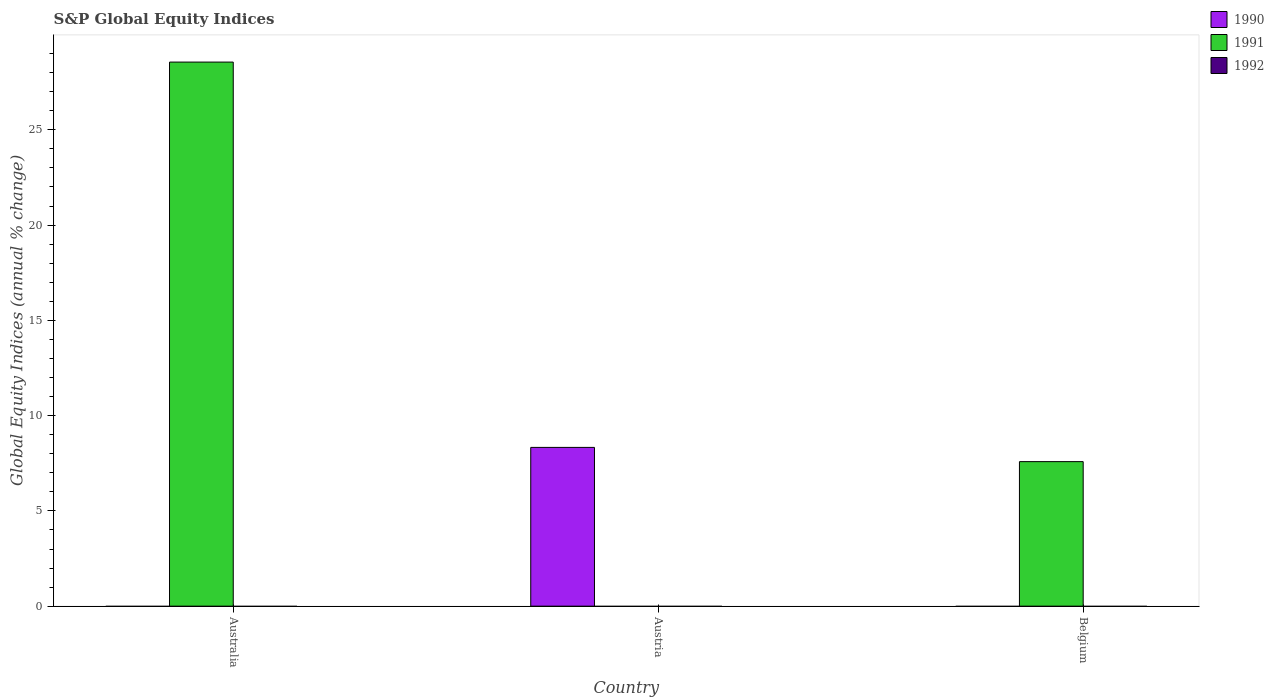How many different coloured bars are there?
Your answer should be very brief. 2. Are the number of bars per tick equal to the number of legend labels?
Your answer should be compact. No. Are the number of bars on each tick of the X-axis equal?
Give a very brief answer. Yes. How many bars are there on the 3rd tick from the left?
Keep it short and to the point. 1. How many bars are there on the 2nd tick from the right?
Provide a succinct answer. 1. In how many cases, is the number of bars for a given country not equal to the number of legend labels?
Provide a short and direct response. 3. What is the global equity indices in 1991 in Australia?
Offer a very short reply. 28.56. Across all countries, what is the maximum global equity indices in 1991?
Your answer should be compact. 28.56. What is the total global equity indices in 1990 in the graph?
Your answer should be compact. 8.33. What is the difference between the global equity indices in 1991 in Australia and that in Belgium?
Provide a succinct answer. 20.97. What is the difference between the global equity indices in 1992 in Austria and the global equity indices in 1991 in Australia?
Give a very brief answer. -28.56. What is the average global equity indices in 1990 per country?
Your answer should be very brief. 2.78. What is the difference between the highest and the lowest global equity indices in 1990?
Offer a terse response. 8.33. In how many countries, is the global equity indices in 1992 greater than the average global equity indices in 1992 taken over all countries?
Provide a short and direct response. 0. How many bars are there?
Keep it short and to the point. 3. Are all the bars in the graph horizontal?
Keep it short and to the point. No. What is the difference between two consecutive major ticks on the Y-axis?
Offer a terse response. 5. Are the values on the major ticks of Y-axis written in scientific E-notation?
Provide a short and direct response. No. Does the graph contain any zero values?
Your answer should be compact. Yes. Does the graph contain grids?
Provide a short and direct response. No. Where does the legend appear in the graph?
Offer a very short reply. Top right. How are the legend labels stacked?
Your answer should be very brief. Vertical. What is the title of the graph?
Make the answer very short. S&P Global Equity Indices. Does "1962" appear as one of the legend labels in the graph?
Provide a succinct answer. No. What is the label or title of the X-axis?
Your answer should be compact. Country. What is the label or title of the Y-axis?
Provide a short and direct response. Global Equity Indices (annual % change). What is the Global Equity Indices (annual % change) of 1991 in Australia?
Your answer should be compact. 28.56. What is the Global Equity Indices (annual % change) of 1990 in Austria?
Keep it short and to the point. 8.33. What is the Global Equity Indices (annual % change) of 1991 in Austria?
Make the answer very short. 0. What is the Global Equity Indices (annual % change) of 1992 in Austria?
Provide a succinct answer. 0. What is the Global Equity Indices (annual % change) of 1991 in Belgium?
Provide a succinct answer. 7.59. What is the Global Equity Indices (annual % change) of 1992 in Belgium?
Keep it short and to the point. 0. Across all countries, what is the maximum Global Equity Indices (annual % change) of 1990?
Offer a very short reply. 8.33. Across all countries, what is the maximum Global Equity Indices (annual % change) of 1991?
Your answer should be compact. 28.56. Across all countries, what is the minimum Global Equity Indices (annual % change) in 1990?
Ensure brevity in your answer.  0. What is the total Global Equity Indices (annual % change) of 1990 in the graph?
Your answer should be very brief. 8.33. What is the total Global Equity Indices (annual % change) of 1991 in the graph?
Make the answer very short. 36.14. What is the total Global Equity Indices (annual % change) in 1992 in the graph?
Keep it short and to the point. 0. What is the difference between the Global Equity Indices (annual % change) in 1991 in Australia and that in Belgium?
Make the answer very short. 20.97. What is the difference between the Global Equity Indices (annual % change) in 1990 in Austria and the Global Equity Indices (annual % change) in 1991 in Belgium?
Ensure brevity in your answer.  0.75. What is the average Global Equity Indices (annual % change) in 1990 per country?
Offer a very short reply. 2.78. What is the average Global Equity Indices (annual % change) of 1991 per country?
Make the answer very short. 12.05. What is the ratio of the Global Equity Indices (annual % change) of 1991 in Australia to that in Belgium?
Ensure brevity in your answer.  3.76. What is the difference between the highest and the lowest Global Equity Indices (annual % change) of 1990?
Keep it short and to the point. 8.33. What is the difference between the highest and the lowest Global Equity Indices (annual % change) of 1991?
Ensure brevity in your answer.  28.56. 